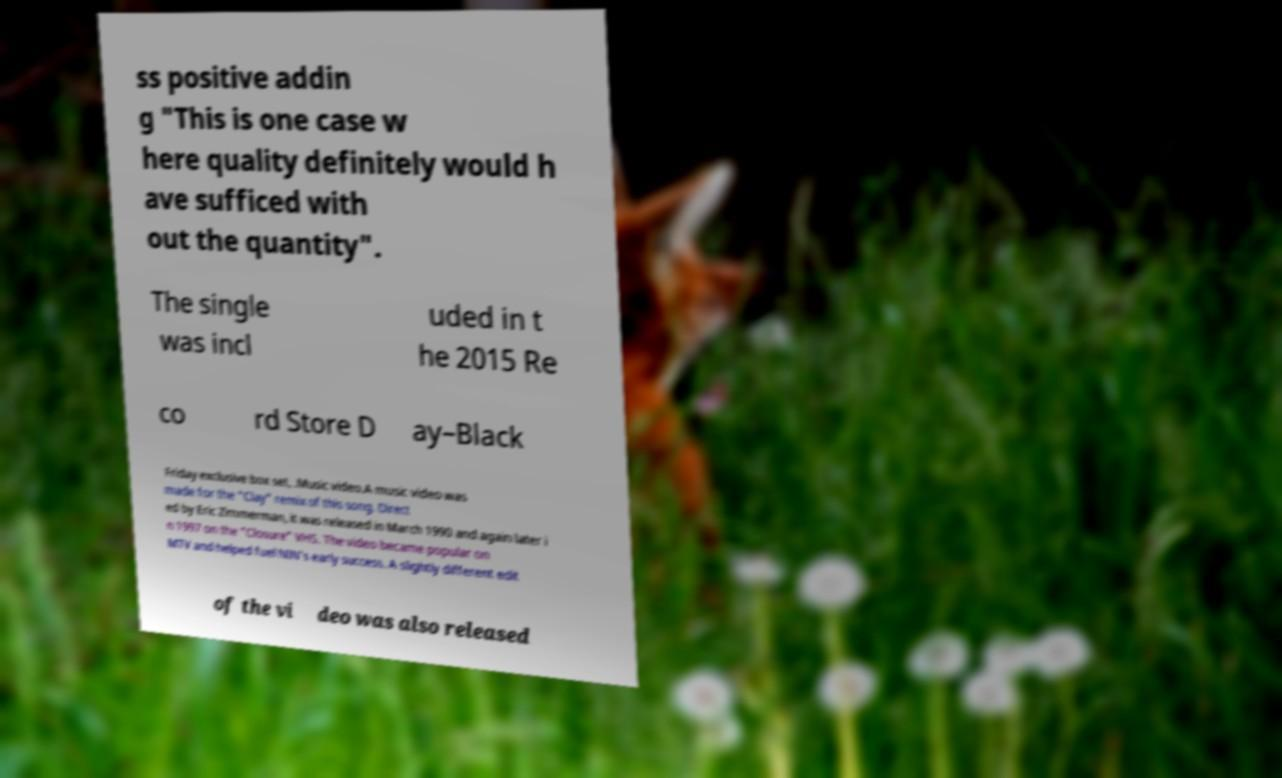Could you assist in decoding the text presented in this image and type it out clearly? ss positive addin g "This is one case w here quality definitely would h ave sufficed with out the quantity". The single was incl uded in t he 2015 Re co rd Store D ay–Black Friday exclusive box set, .Music video.A music video was made for the "Clay" remix of this song. Direct ed by Eric Zimmerman, it was released in March 1990 and again later i n 1997 on the "Closure" VHS. The video became popular on MTV and helped fuel NIN's early success. A slightly different edit of the vi deo was also released 